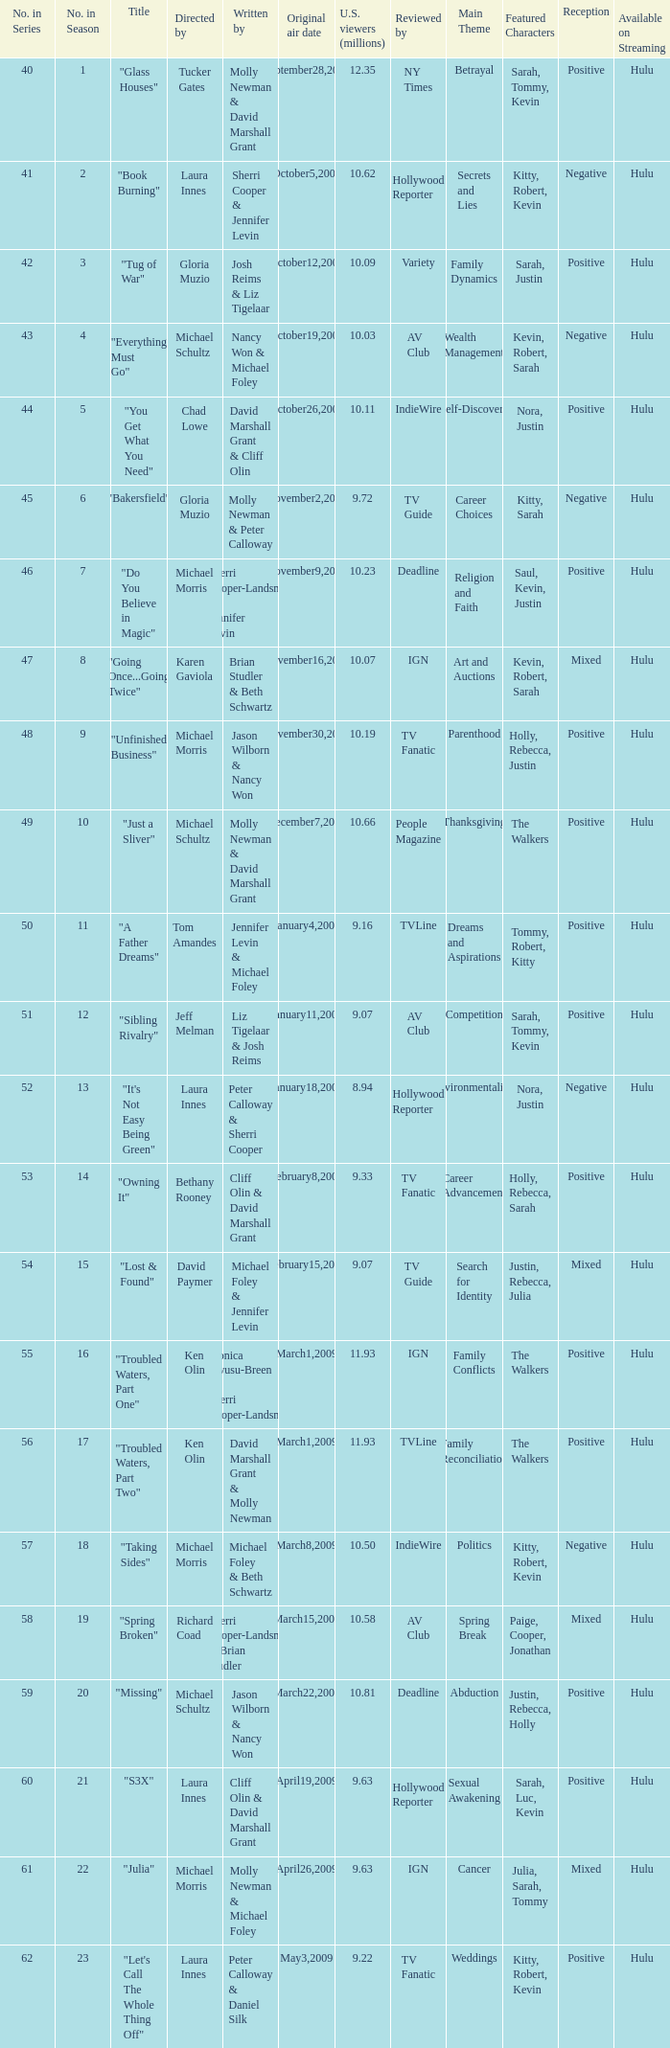Who wrote the episode whose director is Karen Gaviola? Brian Studler & Beth Schwartz. 